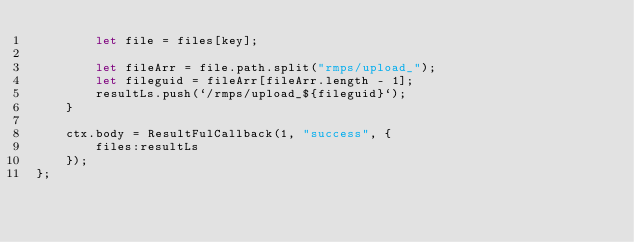Convert code to text. <code><loc_0><loc_0><loc_500><loc_500><_JavaScript_>        let file = files[key];

        let fileArr = file.path.split("rmps/upload_");
        let fileguid = fileArr[fileArr.length - 1];
        resultLs.push(`/rmps/upload_${fileguid}`);
    }

    ctx.body = ResultFulCallback(1, "success", {
        files:resultLs
    });
};</code> 